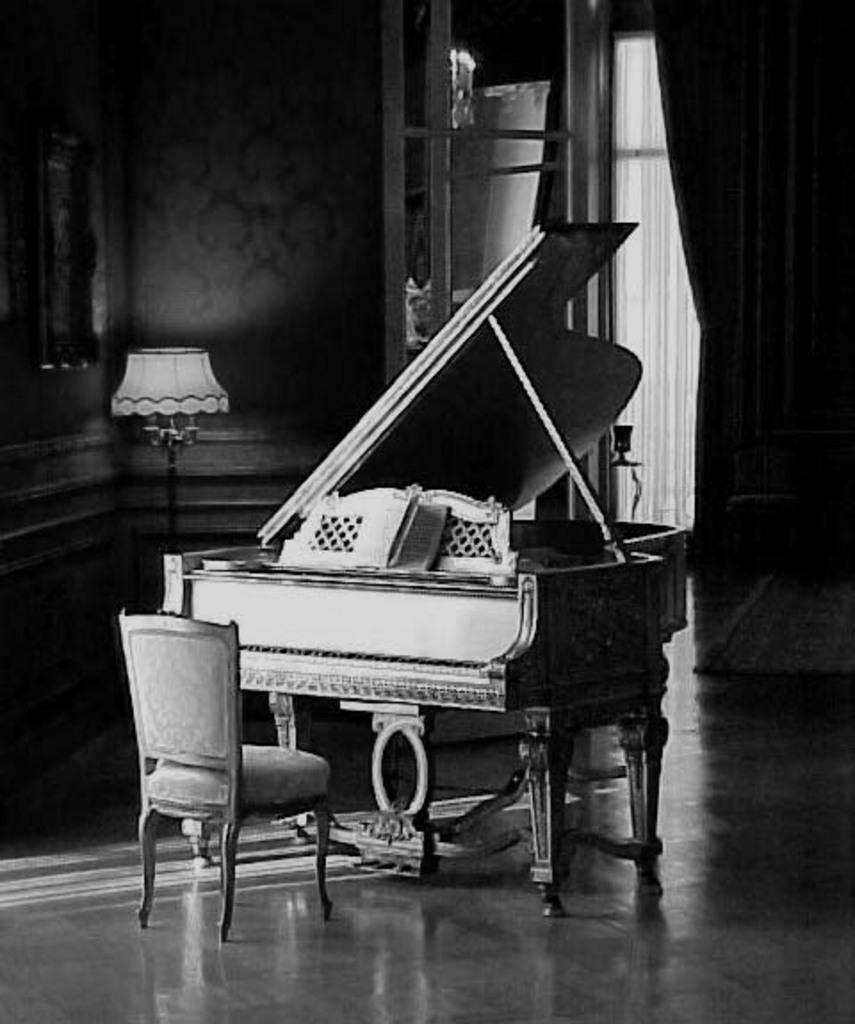What is the main object in the image? There is a piano in the image. What is placed in front of the piano? There is a chair in front of the piano. What other object is near the piano? There is a table lamp beside the piano. What color scheme is used in the image? The image is in black and white color. Can you see the sister of the person playing the piano in the image? There is no person playing the piano or any other person visible in the image. What type of scarf is draped over the piano in the image? There is no scarf present in the image; it only features a piano, chair, and table lamp. 